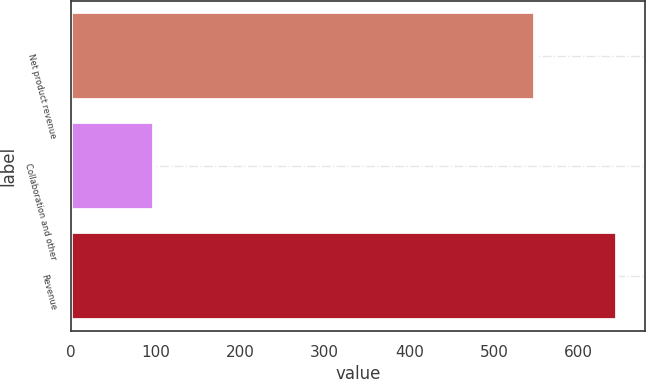Convert chart. <chart><loc_0><loc_0><loc_500><loc_500><bar_chart><fcel>Net product revenue<fcel>Collaboration and other<fcel>Revenue<nl><fcel>548.2<fcel>97.7<fcel>645.9<nl></chart> 